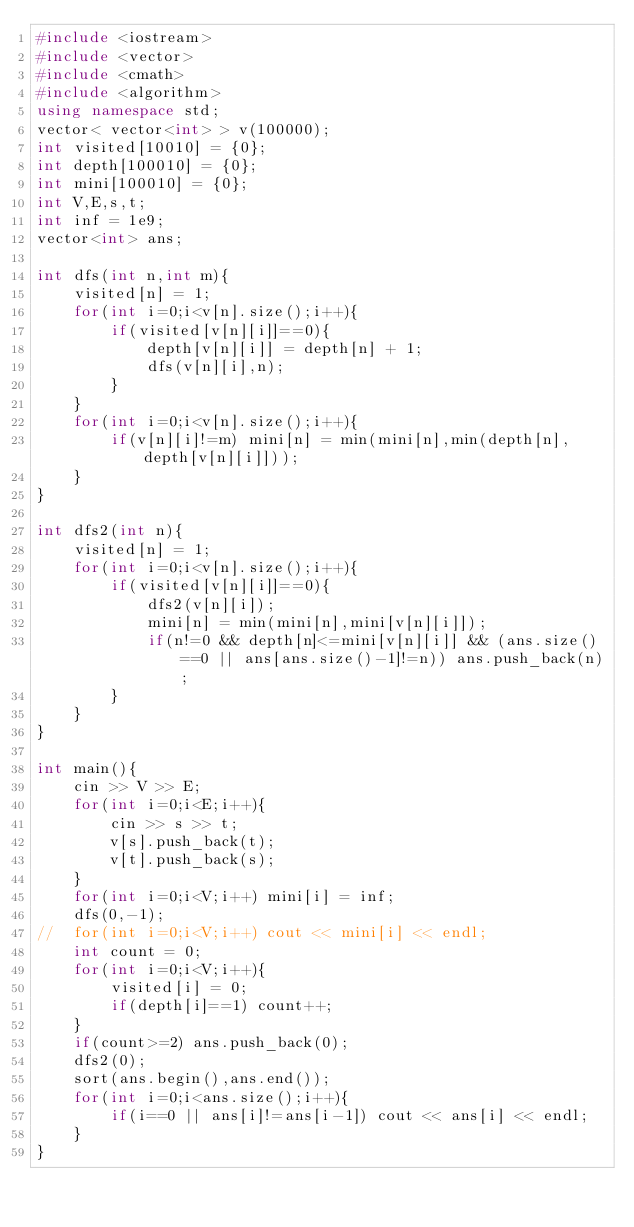Convert code to text. <code><loc_0><loc_0><loc_500><loc_500><_C++_>#include <iostream>
#include <vector>
#include <cmath>
#include <algorithm>
using namespace std;
vector< vector<int> > v(100000);
int visited[10010] = {0};
int depth[100010] = {0};
int mini[100010] = {0};
int V,E,s,t;
int inf = 1e9;
vector<int> ans;

int dfs(int n,int m){
	visited[n] = 1;
	for(int i=0;i<v[n].size();i++){
		if(visited[v[n][i]]==0){
			depth[v[n][i]] = depth[n] + 1;
			dfs(v[n][i],n);
		}
	}
	for(int i=0;i<v[n].size();i++){
		if(v[n][i]!=m) mini[n] = min(mini[n],min(depth[n],depth[v[n][i]]));
	}
}

int dfs2(int n){
	visited[n] = 1;
	for(int i=0;i<v[n].size();i++){
		if(visited[v[n][i]]==0){
			dfs2(v[n][i]);
			mini[n] = min(mini[n],mini[v[n][i]]);
			if(n!=0 && depth[n]<=mini[v[n][i]] && (ans.size()==0 || ans[ans.size()-1]!=n)) ans.push_back(n);
		}
	}
}

int main(){
	cin >> V >> E;
	for(int i=0;i<E;i++){
		cin >> s >> t;
		v[s].push_back(t);
		v[t].push_back(s);
	}
	for(int i=0;i<V;i++) mini[i] = inf;
	dfs(0,-1);
//	for(int i=0;i<V;i++) cout << mini[i] << endl;
	int count = 0;
	for(int i=0;i<V;i++){
		visited[i] = 0;
		if(depth[i]==1) count++;
	}
	if(count>=2) ans.push_back(0);
	dfs2(0);
	sort(ans.begin(),ans.end());
	for(int i=0;i<ans.size();i++){
		if(i==0 || ans[i]!=ans[i-1]) cout << ans[i] << endl;
	}
}
</code> 